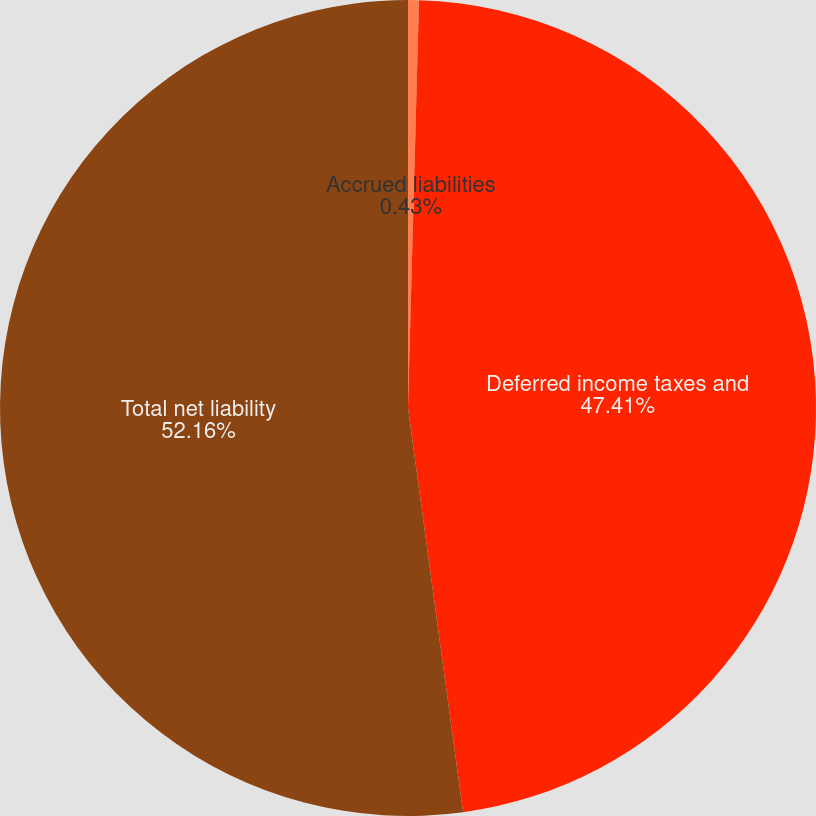Convert chart to OTSL. <chart><loc_0><loc_0><loc_500><loc_500><pie_chart><fcel>Accrued liabilities<fcel>Deferred income taxes and<fcel>Total net liability<nl><fcel>0.43%<fcel>47.41%<fcel>52.15%<nl></chart> 